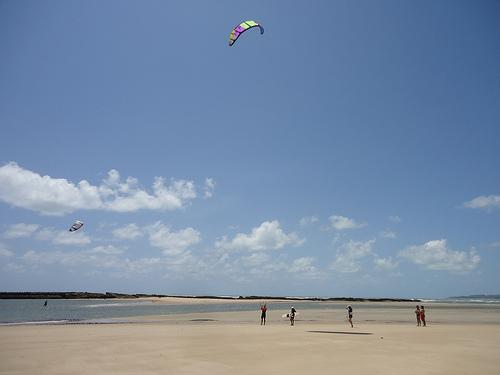Question: why are there people on the beach?
Choices:
A. They are relaxing.
B. They are flying their kites and enjoying their day.
C. They are swimming.
D. They are jogging.
Answer with the letter. Answer: B Question: how many people are in the water?
Choices:
A. Two people.
B. One person in the water.
C. Three people.
D. Four people.
Answer with the letter. Answer: B Question: what color is the sky?
Choices:
A. The sky is blue.
B. Yellow.
C. Pink.
D. Grey.
Answer with the letter. Answer: A Question: what color is the kite to the far right?
Choices:
A. Red.
B. The kite is green,purple, and black.
C. Blue.
D. White.
Answer with the letter. Answer: B Question: where are the five people standing?
Choices:
A. They are standing in the water.
B. They are standing far away.
C. They are standing under the umbrella.
D. They are standing on the sand.
Answer with the letter. Answer: D 